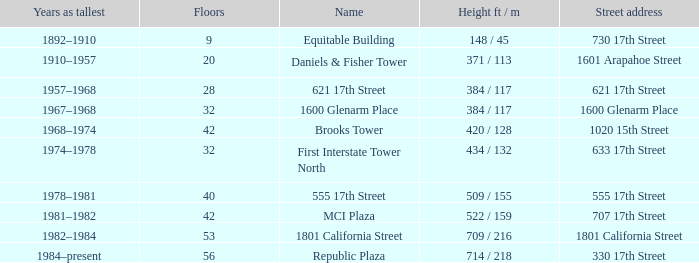Could you parse the entire table? {'header': ['Years as tallest', 'Floors', 'Name', 'Height ft / m', 'Street address'], 'rows': [['1892–1910', '9', 'Equitable Building', '148 / 45', '730 17th Street'], ['1910–1957', '20', 'Daniels & Fisher Tower', '371 / 113', '1601 Arapahoe Street'], ['1957–1968', '28', '621 17th Street', '384 / 117', '621 17th Street'], ['1967–1968', '32', '1600 Glenarm Place', '384 / 117', '1600 Glenarm Place'], ['1968–1974', '42', 'Brooks Tower', '420 / 128', '1020 15th Street'], ['1974–1978', '32', 'First Interstate Tower North', '434 / 132', '633 17th Street'], ['1978–1981', '40', '555 17th Street', '509 / 155', '555 17th Street'], ['1981–1982', '42', 'MCI Plaza', '522 / 159', '707 17th Street'], ['1982–1984', '53', '1801 California Street', '709 / 216', '1801 California Street'], ['1984–present', '56', 'Republic Plaza', '714 / 218', '330 17th Street']]} What is the height of the building with 40 floors? 509 / 155. 